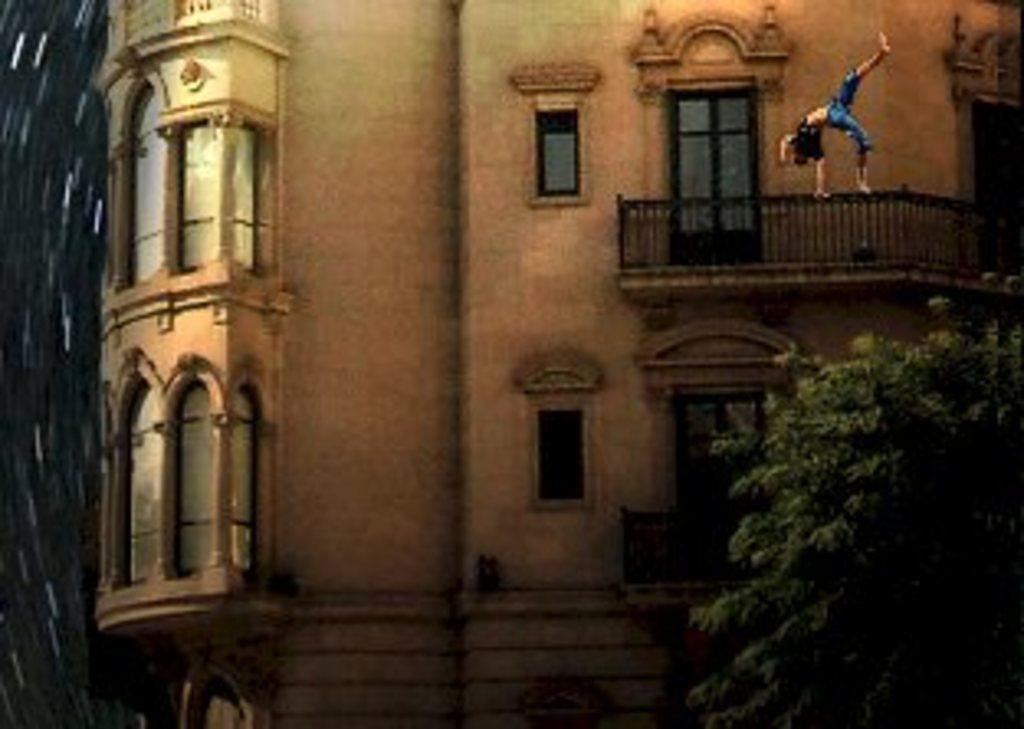What can be seen in the background of the image? There is a building in the background of the image. Where is the lady positioned in the image? The lady is on the railing in the image. What type of vegetation is on the right side of the image? There is a tree on the right side bottom of the image. What is the value of the bead that the fireman is holding in the image? There is no fireman or bead present in the image. How does the lady's action relate to the value of the bead in the image? Since there is no fireman or bead in the image, it is not possible to determine any relationship between the lady's action and the value of a bead. 